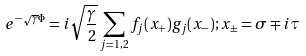<formula> <loc_0><loc_0><loc_500><loc_500>e ^ { - \sqrt { \gamma } \Phi } = i \sqrt { \frac { \gamma } { 2 } } \sum _ { j = 1 , 2 } f _ { j } ( x _ { + } ) g _ { j } ( x _ { - } ) ; x _ { \pm } = \sigma \mp i \tau</formula> 